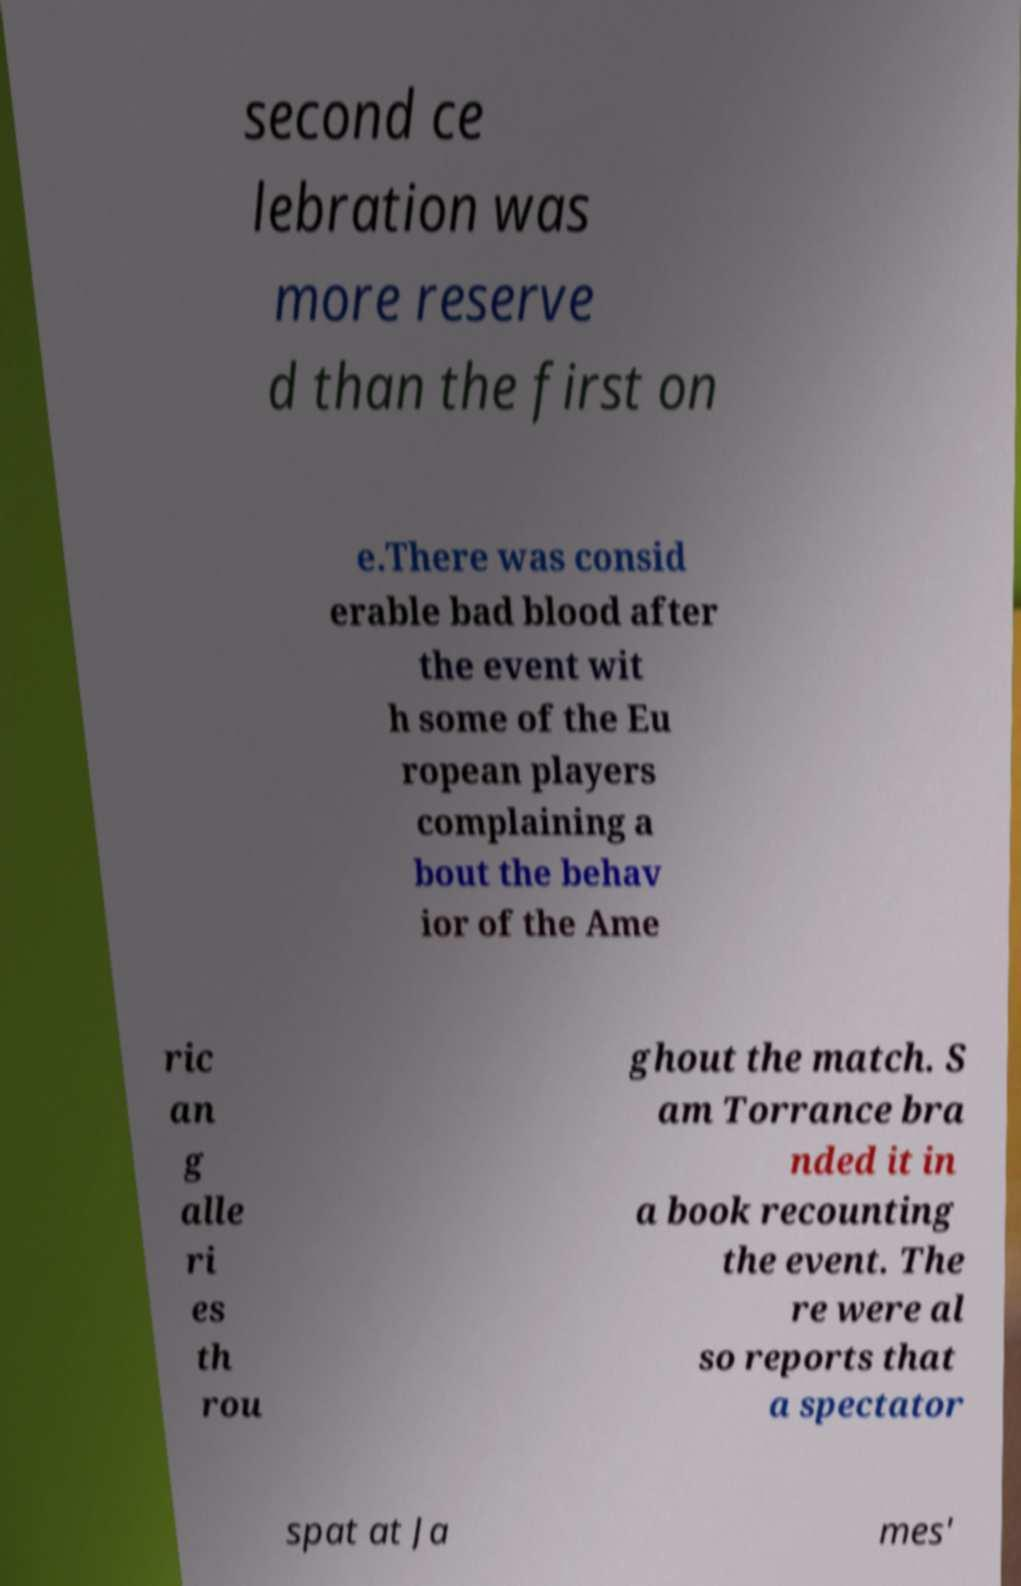I need the written content from this picture converted into text. Can you do that? second ce lebration was more reserve d than the first on e.There was consid erable bad blood after the event wit h some of the Eu ropean players complaining a bout the behav ior of the Ame ric an g alle ri es th rou ghout the match. S am Torrance bra nded it in a book recounting the event. The re were al so reports that a spectator spat at Ja mes' 